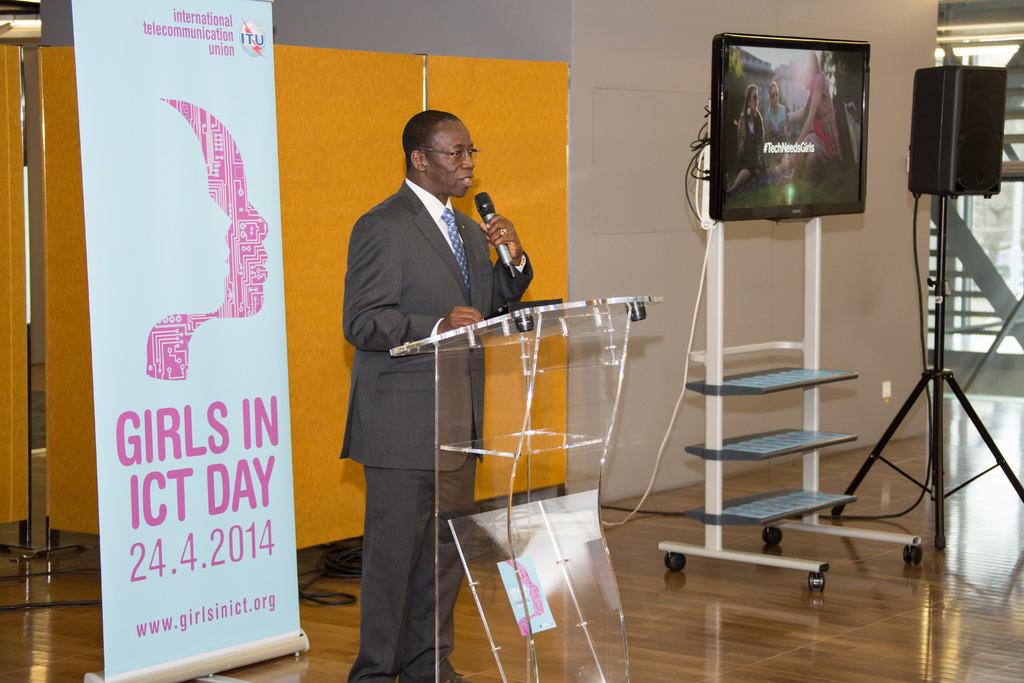<image>
Write a terse but informative summary of the picture. A man stands at a podium next to a banner advertising the girls in ICT day 